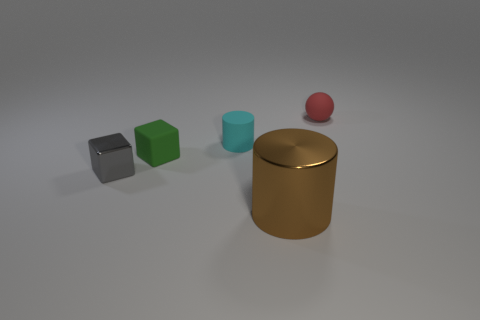There is a brown thing; is it the same shape as the tiny object that is left of the green matte thing?
Make the answer very short. No. There is a tiny gray object that is the same material as the large brown cylinder; what shape is it?
Your response must be concise. Cube. Do the tiny thing that is on the right side of the brown object and the big brown shiny object have the same shape?
Your answer should be very brief. No. What number of cyan things are tiny rubber spheres or rubber things?
Offer a terse response. 1. Are there an equal number of green rubber blocks in front of the tiny green thing and tiny gray shiny cubes left of the small metal object?
Make the answer very short. Yes. The cube that is on the right side of the gray block that is on the left side of the cylinder that is behind the gray object is what color?
Keep it short and to the point. Green. Is there any other thing that is the same color as the small shiny object?
Provide a succinct answer. No. How big is the cylinder in front of the gray cube?
Give a very brief answer. Large. There is a metal object that is the same size as the rubber cylinder; what is its shape?
Give a very brief answer. Cube. Is the cube behind the gray shiny cube made of the same material as the small block in front of the small green matte cube?
Provide a succinct answer. No. 